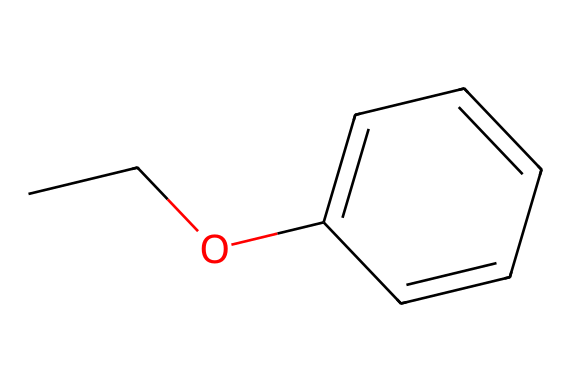What is the name of this compound? The SMILES representation CC(O)c1ccccc1 corresponds to ethyl phenyl ether, as it contains the ethyl group (CC) attached to a phenyl group (c1ccccc1) through an oxygen atom.
Answer: ethyl phenyl ether How many carbon atoms are in this molecule? The structure consists of two carbon atoms from the ethyl group (CC) and six carbon atoms from the phenyl group (c1ccccc1), summing a total of eight carbon atoms.
Answer: eight What type of functional group is present in this compound? The presence of an oxygen atom that connects two carbon-containing groups denotes this molecule as an ether, which is characterized by its general functional group R-O-R'.
Answer: ether How many total hydrogen atoms are in this molecule? The ethyl group (CC) contributes five hydrogen atoms (C2H5), while the phenyl group (C6H5) contributes five hydrogen atoms, leading to a total of ten hydrogen atoms.
Answer: ten Why is this molecule considered an ether? Ethers are defined by having an oxygen atom bonded to two alkyl or aryl groups, and this molecule, ethyl phenyl ether, exhibits that characteristic with the oxygen atom bridging the ethyl group and the phenyl group.
Answer: oxygen bonded to two groups Is this molecule likely to be soluble in water? Ethers typically exhibit lower solubility in water because they do not form strong hydrogen bonds with water molecules compared to alcohols, influenced by the ether's hydrophobic carbon chains.
Answer: no 